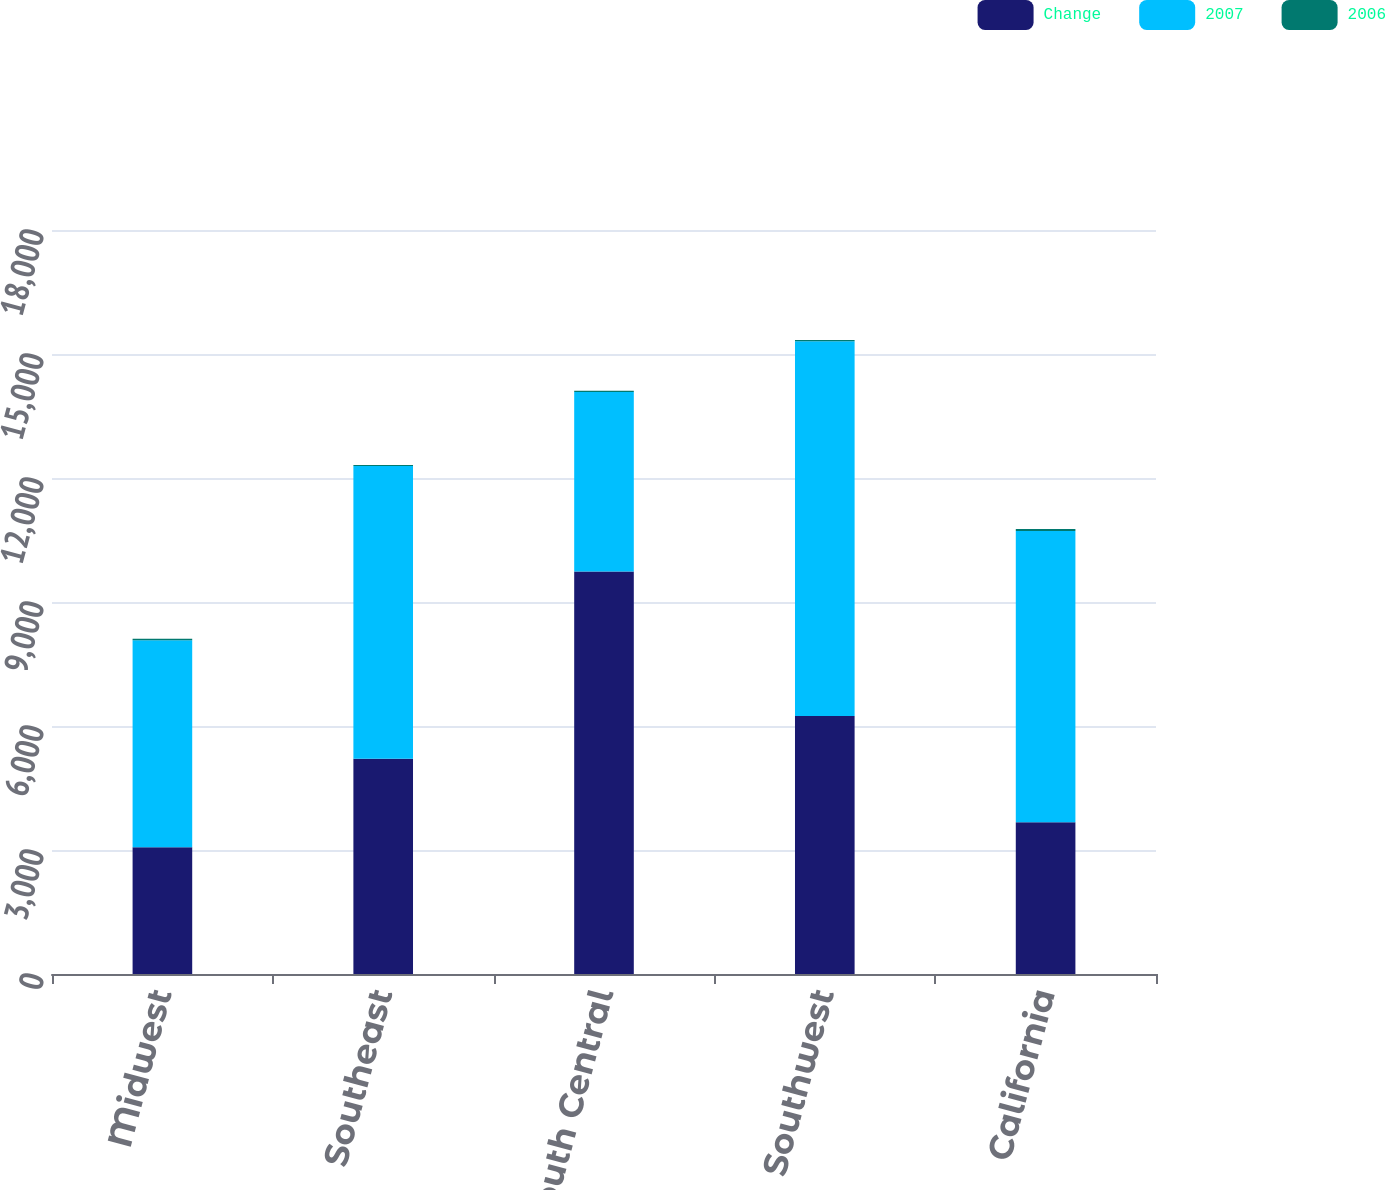<chart> <loc_0><loc_0><loc_500><loc_500><stacked_bar_chart><ecel><fcel>Midwest<fcel>Southeast<fcel>South Central<fcel>Southwest<fcel>California<nl><fcel>Change<fcel>3065<fcel>5206<fcel>9740<fcel>6244<fcel>3670<nl><fcel>2007<fcel>5007<fcel>7082<fcel>4338.5<fcel>9065<fcel>7050<nl><fcel>2006<fcel>39<fcel>26<fcel>34<fcel>31<fcel>48<nl></chart> 